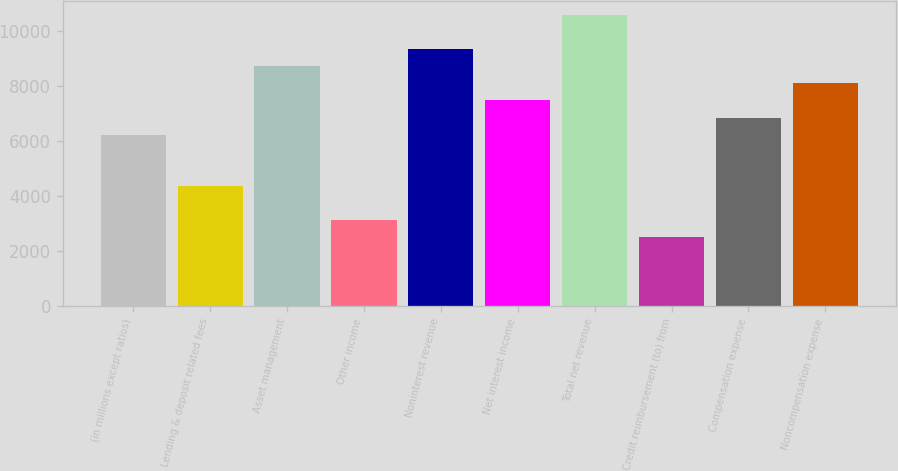Convert chart. <chart><loc_0><loc_0><loc_500><loc_500><bar_chart><fcel>(in millions except ratios)<fcel>Lending & deposit related fees<fcel>Asset management<fcel>Other income<fcel>Noninterest revenue<fcel>Net interest income<fcel>Total net revenue<fcel>Credit reimbursement (to) from<fcel>Compensation expense<fcel>Noncompensation expense<nl><fcel>6241<fcel>4376.5<fcel>8727<fcel>3133.5<fcel>9348.5<fcel>7484<fcel>10591.5<fcel>2512<fcel>6862.5<fcel>8105.5<nl></chart> 